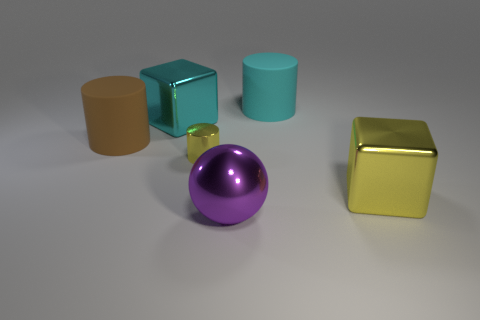Subtract all large cylinders. How many cylinders are left? 1 Subtract 1 cylinders. How many cylinders are left? 2 Add 2 large green metal cubes. How many objects exist? 8 Subtract all cubes. How many objects are left? 4 Add 6 balls. How many balls exist? 7 Subtract 0 brown balls. How many objects are left? 6 Subtract all big shiny balls. Subtract all red spheres. How many objects are left? 5 Add 5 yellow metallic blocks. How many yellow metallic blocks are left? 6 